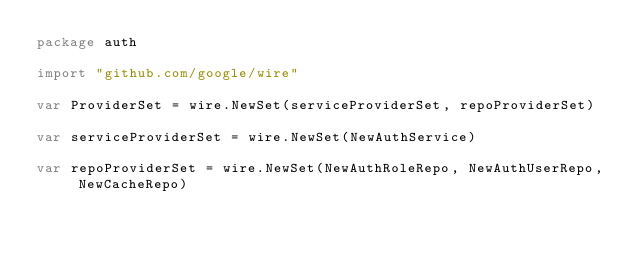<code> <loc_0><loc_0><loc_500><loc_500><_Go_>package auth

import "github.com/google/wire"

var ProviderSet = wire.NewSet(serviceProviderSet, repoProviderSet)

var serviceProviderSet = wire.NewSet(NewAuthService)

var repoProviderSet = wire.NewSet(NewAuthRoleRepo, NewAuthUserRepo, NewCacheRepo)
</code> 